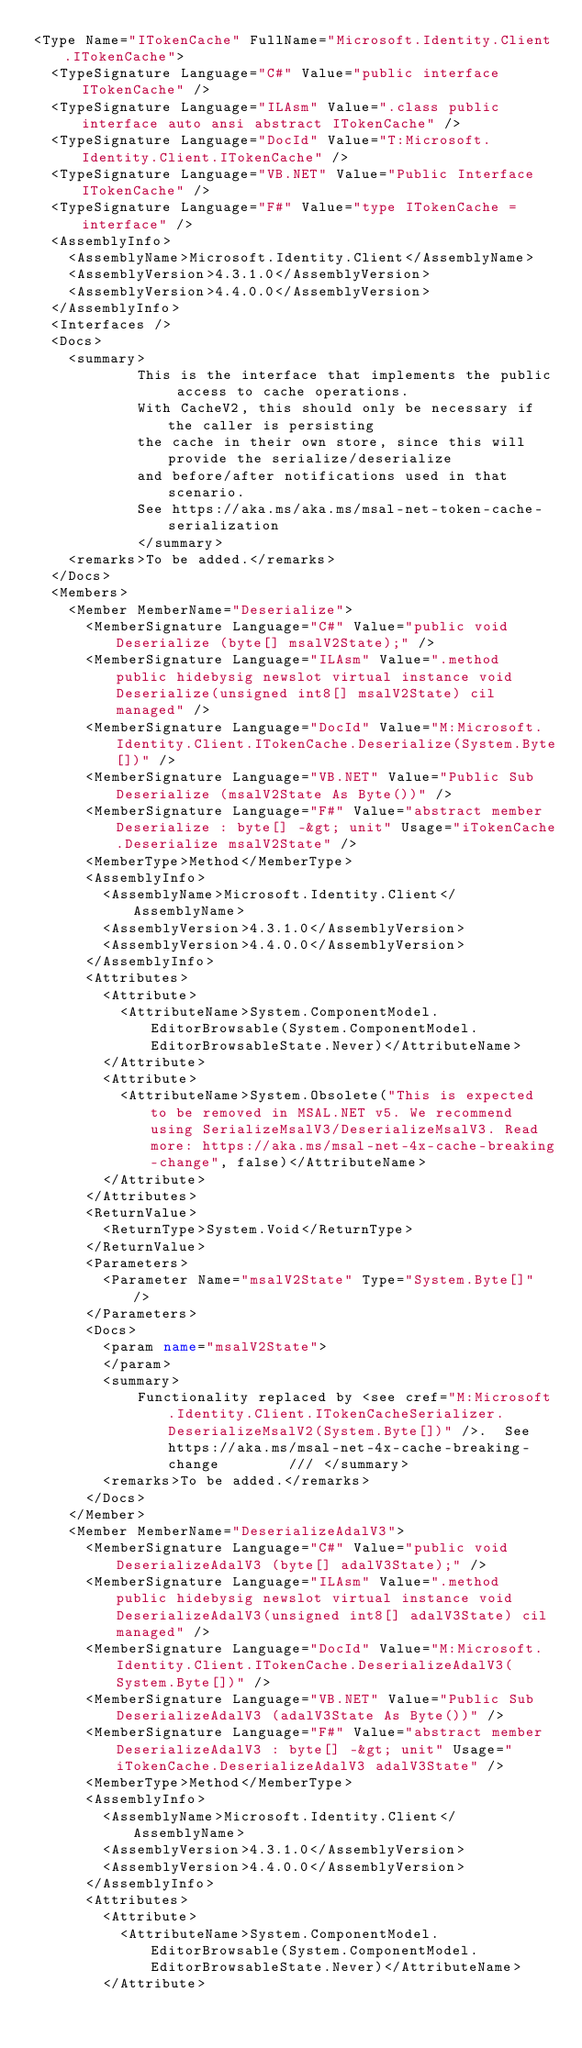Convert code to text. <code><loc_0><loc_0><loc_500><loc_500><_XML_><Type Name="ITokenCache" FullName="Microsoft.Identity.Client.ITokenCache">
  <TypeSignature Language="C#" Value="public interface ITokenCache" />
  <TypeSignature Language="ILAsm" Value=".class public interface auto ansi abstract ITokenCache" />
  <TypeSignature Language="DocId" Value="T:Microsoft.Identity.Client.ITokenCache" />
  <TypeSignature Language="VB.NET" Value="Public Interface ITokenCache" />
  <TypeSignature Language="F#" Value="type ITokenCache = interface" />
  <AssemblyInfo>
    <AssemblyName>Microsoft.Identity.Client</AssemblyName>
    <AssemblyVersion>4.3.1.0</AssemblyVersion>
    <AssemblyVersion>4.4.0.0</AssemblyVersion>
  </AssemblyInfo>
  <Interfaces />
  <Docs>
    <summary>
            This is the interface that implements the public access to cache operations.
            With CacheV2, this should only be necessary if the caller is persisting
            the cache in their own store, since this will provide the serialize/deserialize
            and before/after notifications used in that scenario.
            See https://aka.ms/aka.ms/msal-net-token-cache-serialization
            </summary>
    <remarks>To be added.</remarks>
  </Docs>
  <Members>
    <Member MemberName="Deserialize">
      <MemberSignature Language="C#" Value="public void Deserialize (byte[] msalV2State);" />
      <MemberSignature Language="ILAsm" Value=".method public hidebysig newslot virtual instance void Deserialize(unsigned int8[] msalV2State) cil managed" />
      <MemberSignature Language="DocId" Value="M:Microsoft.Identity.Client.ITokenCache.Deserialize(System.Byte[])" />
      <MemberSignature Language="VB.NET" Value="Public Sub Deserialize (msalV2State As Byte())" />
      <MemberSignature Language="F#" Value="abstract member Deserialize : byte[] -&gt; unit" Usage="iTokenCache.Deserialize msalV2State" />
      <MemberType>Method</MemberType>
      <AssemblyInfo>
        <AssemblyName>Microsoft.Identity.Client</AssemblyName>
        <AssemblyVersion>4.3.1.0</AssemblyVersion>
        <AssemblyVersion>4.4.0.0</AssemblyVersion>
      </AssemblyInfo>
      <Attributes>
        <Attribute>
          <AttributeName>System.ComponentModel.EditorBrowsable(System.ComponentModel.EditorBrowsableState.Never)</AttributeName>
        </Attribute>
        <Attribute>
          <AttributeName>System.Obsolete("This is expected to be removed in MSAL.NET v5. We recommend using SerializeMsalV3/DeserializeMsalV3. Read more: https://aka.ms/msal-net-4x-cache-breaking-change", false)</AttributeName>
        </Attribute>
      </Attributes>
      <ReturnValue>
        <ReturnType>System.Void</ReturnType>
      </ReturnValue>
      <Parameters>
        <Parameter Name="msalV2State" Type="System.Byte[]" />
      </Parameters>
      <Docs>
        <param name="msalV2State">
        </param>
        <summary>
            Functionality replaced by <see cref="M:Microsoft.Identity.Client.ITokenCacheSerializer.DeserializeMsalV2(System.Byte[])" />.  See https://aka.ms/msal-net-4x-cache-breaking-change        /// </summary>
        <remarks>To be added.</remarks>
      </Docs>
    </Member>
    <Member MemberName="DeserializeAdalV3">
      <MemberSignature Language="C#" Value="public void DeserializeAdalV3 (byte[] adalV3State);" />
      <MemberSignature Language="ILAsm" Value=".method public hidebysig newslot virtual instance void DeserializeAdalV3(unsigned int8[] adalV3State) cil managed" />
      <MemberSignature Language="DocId" Value="M:Microsoft.Identity.Client.ITokenCache.DeserializeAdalV3(System.Byte[])" />
      <MemberSignature Language="VB.NET" Value="Public Sub DeserializeAdalV3 (adalV3State As Byte())" />
      <MemberSignature Language="F#" Value="abstract member DeserializeAdalV3 : byte[] -&gt; unit" Usage="iTokenCache.DeserializeAdalV3 adalV3State" />
      <MemberType>Method</MemberType>
      <AssemblyInfo>
        <AssemblyName>Microsoft.Identity.Client</AssemblyName>
        <AssemblyVersion>4.3.1.0</AssemblyVersion>
        <AssemblyVersion>4.4.0.0</AssemblyVersion>
      </AssemblyInfo>
      <Attributes>
        <Attribute>
          <AttributeName>System.ComponentModel.EditorBrowsable(System.ComponentModel.EditorBrowsableState.Never)</AttributeName>
        </Attribute></code> 